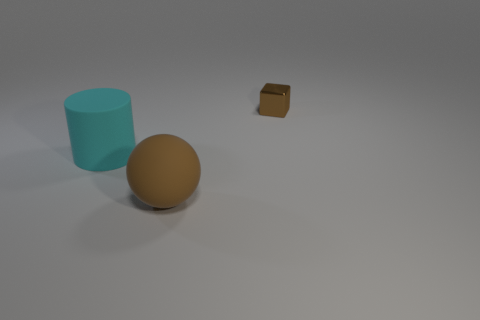Subtract all spheres. How many objects are left? 2 Add 1 rubber spheres. How many objects exist? 4 Subtract 0 gray cubes. How many objects are left? 3 Subtract all cyan spheres. Subtract all red cylinders. How many spheres are left? 1 Subtract all brown objects. Subtract all brown matte things. How many objects are left? 0 Add 1 metallic blocks. How many metallic blocks are left? 2 Add 3 big gray metallic objects. How many big gray metallic objects exist? 3 